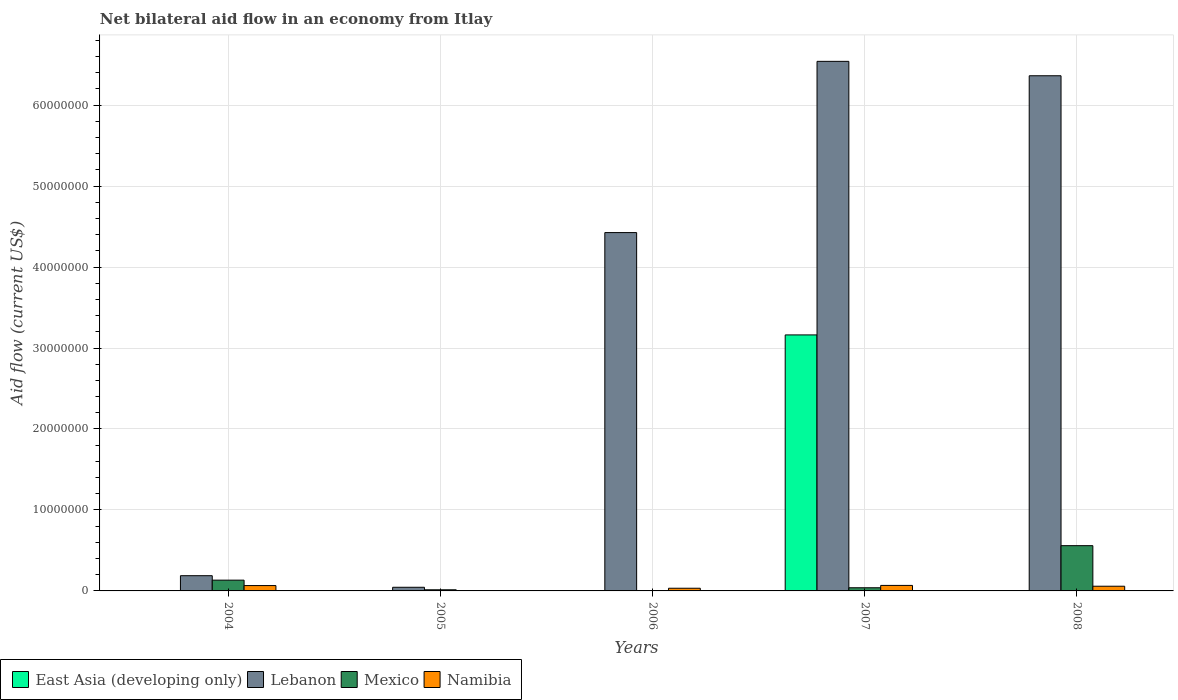How many different coloured bars are there?
Your answer should be compact. 4. How many groups of bars are there?
Your answer should be very brief. 5. How many bars are there on the 2nd tick from the right?
Ensure brevity in your answer.  4. In how many cases, is the number of bars for a given year not equal to the number of legend labels?
Keep it short and to the point. 4. What is the net bilateral aid flow in East Asia (developing only) in 2008?
Give a very brief answer. 0. Across all years, what is the maximum net bilateral aid flow in East Asia (developing only)?
Ensure brevity in your answer.  3.16e+07. Across all years, what is the minimum net bilateral aid flow in Lebanon?
Your response must be concise. 4.50e+05. In which year was the net bilateral aid flow in Namibia maximum?
Offer a very short reply. 2007. What is the total net bilateral aid flow in Namibia in the graph?
Keep it short and to the point. 2.26e+06. What is the difference between the net bilateral aid flow in Lebanon in 2005 and that in 2006?
Provide a succinct answer. -4.38e+07. What is the difference between the net bilateral aid flow in East Asia (developing only) in 2007 and the net bilateral aid flow in Mexico in 2006?
Ensure brevity in your answer.  3.16e+07. What is the average net bilateral aid flow in Mexico per year?
Make the answer very short. 1.49e+06. In the year 2007, what is the difference between the net bilateral aid flow in Namibia and net bilateral aid flow in Lebanon?
Offer a very short reply. -6.47e+07. What is the ratio of the net bilateral aid flow in Lebanon in 2007 to that in 2008?
Offer a terse response. 1.03. What is the difference between the highest and the lowest net bilateral aid flow in East Asia (developing only)?
Ensure brevity in your answer.  3.16e+07. In how many years, is the net bilateral aid flow in Mexico greater than the average net bilateral aid flow in Mexico taken over all years?
Give a very brief answer. 1. Is the sum of the net bilateral aid flow in Lebanon in 2004 and 2007 greater than the maximum net bilateral aid flow in East Asia (developing only) across all years?
Your answer should be very brief. Yes. Is it the case that in every year, the sum of the net bilateral aid flow in Namibia and net bilateral aid flow in Lebanon is greater than the net bilateral aid flow in Mexico?
Your answer should be very brief. Yes. Are the values on the major ticks of Y-axis written in scientific E-notation?
Offer a terse response. No. Where does the legend appear in the graph?
Your answer should be compact. Bottom left. What is the title of the graph?
Offer a terse response. Net bilateral aid flow in an economy from Itlay. Does "Vietnam" appear as one of the legend labels in the graph?
Keep it short and to the point. No. What is the Aid flow (current US$) in Lebanon in 2004?
Make the answer very short. 1.88e+06. What is the Aid flow (current US$) in Mexico in 2004?
Your response must be concise. 1.33e+06. What is the Aid flow (current US$) of East Asia (developing only) in 2005?
Keep it short and to the point. 0. What is the Aid flow (current US$) of Lebanon in 2006?
Keep it short and to the point. 4.43e+07. What is the Aid flow (current US$) of Mexico in 2006?
Offer a very short reply. 2.00e+04. What is the Aid flow (current US$) in East Asia (developing only) in 2007?
Provide a succinct answer. 3.16e+07. What is the Aid flow (current US$) in Lebanon in 2007?
Provide a short and direct response. 6.54e+07. What is the Aid flow (current US$) in Mexico in 2007?
Your answer should be compact. 3.90e+05. What is the Aid flow (current US$) in Namibia in 2007?
Keep it short and to the point. 6.80e+05. What is the Aid flow (current US$) of East Asia (developing only) in 2008?
Give a very brief answer. 0. What is the Aid flow (current US$) in Lebanon in 2008?
Make the answer very short. 6.36e+07. What is the Aid flow (current US$) of Mexico in 2008?
Ensure brevity in your answer.  5.59e+06. What is the Aid flow (current US$) of Namibia in 2008?
Make the answer very short. 5.80e+05. Across all years, what is the maximum Aid flow (current US$) in East Asia (developing only)?
Your response must be concise. 3.16e+07. Across all years, what is the maximum Aid flow (current US$) in Lebanon?
Make the answer very short. 6.54e+07. Across all years, what is the maximum Aid flow (current US$) in Mexico?
Your answer should be compact. 5.59e+06. Across all years, what is the maximum Aid flow (current US$) of Namibia?
Your answer should be very brief. 6.80e+05. Across all years, what is the minimum Aid flow (current US$) of Mexico?
Provide a short and direct response. 2.00e+04. What is the total Aid flow (current US$) of East Asia (developing only) in the graph?
Your answer should be compact. 3.16e+07. What is the total Aid flow (current US$) of Lebanon in the graph?
Provide a succinct answer. 1.76e+08. What is the total Aid flow (current US$) of Mexico in the graph?
Offer a terse response. 7.47e+06. What is the total Aid flow (current US$) of Namibia in the graph?
Give a very brief answer. 2.26e+06. What is the difference between the Aid flow (current US$) in Lebanon in 2004 and that in 2005?
Ensure brevity in your answer.  1.43e+06. What is the difference between the Aid flow (current US$) of Mexico in 2004 and that in 2005?
Provide a succinct answer. 1.19e+06. What is the difference between the Aid flow (current US$) in Namibia in 2004 and that in 2005?
Your response must be concise. 6.50e+05. What is the difference between the Aid flow (current US$) of Lebanon in 2004 and that in 2006?
Offer a very short reply. -4.24e+07. What is the difference between the Aid flow (current US$) of Mexico in 2004 and that in 2006?
Offer a terse response. 1.31e+06. What is the difference between the Aid flow (current US$) of Lebanon in 2004 and that in 2007?
Offer a very short reply. -6.35e+07. What is the difference between the Aid flow (current US$) in Mexico in 2004 and that in 2007?
Offer a very short reply. 9.40e+05. What is the difference between the Aid flow (current US$) of Lebanon in 2004 and that in 2008?
Give a very brief answer. -6.18e+07. What is the difference between the Aid flow (current US$) in Mexico in 2004 and that in 2008?
Offer a terse response. -4.26e+06. What is the difference between the Aid flow (current US$) of Lebanon in 2005 and that in 2006?
Provide a short and direct response. -4.38e+07. What is the difference between the Aid flow (current US$) in Mexico in 2005 and that in 2006?
Ensure brevity in your answer.  1.20e+05. What is the difference between the Aid flow (current US$) of Namibia in 2005 and that in 2006?
Offer a very short reply. -3.20e+05. What is the difference between the Aid flow (current US$) in Lebanon in 2005 and that in 2007?
Offer a terse response. -6.50e+07. What is the difference between the Aid flow (current US$) of Namibia in 2005 and that in 2007?
Your answer should be compact. -6.70e+05. What is the difference between the Aid flow (current US$) of Lebanon in 2005 and that in 2008?
Provide a short and direct response. -6.32e+07. What is the difference between the Aid flow (current US$) of Mexico in 2005 and that in 2008?
Make the answer very short. -5.45e+06. What is the difference between the Aid flow (current US$) of Namibia in 2005 and that in 2008?
Offer a very short reply. -5.70e+05. What is the difference between the Aid flow (current US$) in Lebanon in 2006 and that in 2007?
Provide a succinct answer. -2.12e+07. What is the difference between the Aid flow (current US$) of Mexico in 2006 and that in 2007?
Keep it short and to the point. -3.70e+05. What is the difference between the Aid flow (current US$) of Namibia in 2006 and that in 2007?
Make the answer very short. -3.50e+05. What is the difference between the Aid flow (current US$) in Lebanon in 2006 and that in 2008?
Provide a succinct answer. -1.94e+07. What is the difference between the Aid flow (current US$) of Mexico in 2006 and that in 2008?
Provide a short and direct response. -5.57e+06. What is the difference between the Aid flow (current US$) in Lebanon in 2007 and that in 2008?
Ensure brevity in your answer.  1.78e+06. What is the difference between the Aid flow (current US$) of Mexico in 2007 and that in 2008?
Offer a terse response. -5.20e+06. What is the difference between the Aid flow (current US$) in Namibia in 2007 and that in 2008?
Offer a very short reply. 1.00e+05. What is the difference between the Aid flow (current US$) of Lebanon in 2004 and the Aid flow (current US$) of Mexico in 2005?
Offer a very short reply. 1.74e+06. What is the difference between the Aid flow (current US$) in Lebanon in 2004 and the Aid flow (current US$) in Namibia in 2005?
Your response must be concise. 1.87e+06. What is the difference between the Aid flow (current US$) of Mexico in 2004 and the Aid flow (current US$) of Namibia in 2005?
Provide a short and direct response. 1.32e+06. What is the difference between the Aid flow (current US$) of Lebanon in 2004 and the Aid flow (current US$) of Mexico in 2006?
Provide a succinct answer. 1.86e+06. What is the difference between the Aid flow (current US$) of Lebanon in 2004 and the Aid flow (current US$) of Namibia in 2006?
Offer a terse response. 1.55e+06. What is the difference between the Aid flow (current US$) in Lebanon in 2004 and the Aid flow (current US$) in Mexico in 2007?
Ensure brevity in your answer.  1.49e+06. What is the difference between the Aid flow (current US$) of Lebanon in 2004 and the Aid flow (current US$) of Namibia in 2007?
Ensure brevity in your answer.  1.20e+06. What is the difference between the Aid flow (current US$) of Mexico in 2004 and the Aid flow (current US$) of Namibia in 2007?
Ensure brevity in your answer.  6.50e+05. What is the difference between the Aid flow (current US$) in Lebanon in 2004 and the Aid flow (current US$) in Mexico in 2008?
Your answer should be very brief. -3.71e+06. What is the difference between the Aid flow (current US$) of Lebanon in 2004 and the Aid flow (current US$) of Namibia in 2008?
Provide a succinct answer. 1.30e+06. What is the difference between the Aid flow (current US$) of Mexico in 2004 and the Aid flow (current US$) of Namibia in 2008?
Ensure brevity in your answer.  7.50e+05. What is the difference between the Aid flow (current US$) of Lebanon in 2005 and the Aid flow (current US$) of Namibia in 2006?
Your response must be concise. 1.20e+05. What is the difference between the Aid flow (current US$) of Lebanon in 2005 and the Aid flow (current US$) of Mexico in 2007?
Offer a very short reply. 6.00e+04. What is the difference between the Aid flow (current US$) in Mexico in 2005 and the Aid flow (current US$) in Namibia in 2007?
Your answer should be compact. -5.40e+05. What is the difference between the Aid flow (current US$) in Lebanon in 2005 and the Aid flow (current US$) in Mexico in 2008?
Ensure brevity in your answer.  -5.14e+06. What is the difference between the Aid flow (current US$) in Lebanon in 2005 and the Aid flow (current US$) in Namibia in 2008?
Ensure brevity in your answer.  -1.30e+05. What is the difference between the Aid flow (current US$) of Mexico in 2005 and the Aid flow (current US$) of Namibia in 2008?
Offer a terse response. -4.40e+05. What is the difference between the Aid flow (current US$) in Lebanon in 2006 and the Aid flow (current US$) in Mexico in 2007?
Your answer should be very brief. 4.39e+07. What is the difference between the Aid flow (current US$) of Lebanon in 2006 and the Aid flow (current US$) of Namibia in 2007?
Give a very brief answer. 4.36e+07. What is the difference between the Aid flow (current US$) of Mexico in 2006 and the Aid flow (current US$) of Namibia in 2007?
Your answer should be very brief. -6.60e+05. What is the difference between the Aid flow (current US$) in Lebanon in 2006 and the Aid flow (current US$) in Mexico in 2008?
Ensure brevity in your answer.  3.87e+07. What is the difference between the Aid flow (current US$) of Lebanon in 2006 and the Aid flow (current US$) of Namibia in 2008?
Offer a very short reply. 4.37e+07. What is the difference between the Aid flow (current US$) of Mexico in 2006 and the Aid flow (current US$) of Namibia in 2008?
Your answer should be very brief. -5.60e+05. What is the difference between the Aid flow (current US$) of East Asia (developing only) in 2007 and the Aid flow (current US$) of Lebanon in 2008?
Offer a terse response. -3.20e+07. What is the difference between the Aid flow (current US$) of East Asia (developing only) in 2007 and the Aid flow (current US$) of Mexico in 2008?
Offer a terse response. 2.60e+07. What is the difference between the Aid flow (current US$) in East Asia (developing only) in 2007 and the Aid flow (current US$) in Namibia in 2008?
Make the answer very short. 3.10e+07. What is the difference between the Aid flow (current US$) in Lebanon in 2007 and the Aid flow (current US$) in Mexico in 2008?
Your response must be concise. 5.98e+07. What is the difference between the Aid flow (current US$) in Lebanon in 2007 and the Aid flow (current US$) in Namibia in 2008?
Your answer should be compact. 6.48e+07. What is the difference between the Aid flow (current US$) of Mexico in 2007 and the Aid flow (current US$) of Namibia in 2008?
Make the answer very short. -1.90e+05. What is the average Aid flow (current US$) in East Asia (developing only) per year?
Your answer should be compact. 6.32e+06. What is the average Aid flow (current US$) of Lebanon per year?
Ensure brevity in your answer.  3.51e+07. What is the average Aid flow (current US$) of Mexico per year?
Your answer should be compact. 1.49e+06. What is the average Aid flow (current US$) of Namibia per year?
Your answer should be compact. 4.52e+05. In the year 2004, what is the difference between the Aid flow (current US$) in Lebanon and Aid flow (current US$) in Namibia?
Your response must be concise. 1.22e+06. In the year 2004, what is the difference between the Aid flow (current US$) of Mexico and Aid flow (current US$) of Namibia?
Provide a short and direct response. 6.70e+05. In the year 2005, what is the difference between the Aid flow (current US$) of Lebanon and Aid flow (current US$) of Namibia?
Provide a succinct answer. 4.40e+05. In the year 2006, what is the difference between the Aid flow (current US$) of Lebanon and Aid flow (current US$) of Mexico?
Your answer should be compact. 4.42e+07. In the year 2006, what is the difference between the Aid flow (current US$) of Lebanon and Aid flow (current US$) of Namibia?
Provide a succinct answer. 4.39e+07. In the year 2006, what is the difference between the Aid flow (current US$) of Mexico and Aid flow (current US$) of Namibia?
Your response must be concise. -3.10e+05. In the year 2007, what is the difference between the Aid flow (current US$) in East Asia (developing only) and Aid flow (current US$) in Lebanon?
Keep it short and to the point. -3.38e+07. In the year 2007, what is the difference between the Aid flow (current US$) of East Asia (developing only) and Aid flow (current US$) of Mexico?
Offer a very short reply. 3.12e+07. In the year 2007, what is the difference between the Aid flow (current US$) of East Asia (developing only) and Aid flow (current US$) of Namibia?
Your response must be concise. 3.09e+07. In the year 2007, what is the difference between the Aid flow (current US$) in Lebanon and Aid flow (current US$) in Mexico?
Provide a short and direct response. 6.50e+07. In the year 2007, what is the difference between the Aid flow (current US$) of Lebanon and Aid flow (current US$) of Namibia?
Provide a short and direct response. 6.47e+07. In the year 2008, what is the difference between the Aid flow (current US$) in Lebanon and Aid flow (current US$) in Mexico?
Provide a succinct answer. 5.80e+07. In the year 2008, what is the difference between the Aid flow (current US$) in Lebanon and Aid flow (current US$) in Namibia?
Offer a very short reply. 6.30e+07. In the year 2008, what is the difference between the Aid flow (current US$) of Mexico and Aid flow (current US$) of Namibia?
Make the answer very short. 5.01e+06. What is the ratio of the Aid flow (current US$) in Lebanon in 2004 to that in 2005?
Your response must be concise. 4.18. What is the ratio of the Aid flow (current US$) of Lebanon in 2004 to that in 2006?
Provide a short and direct response. 0.04. What is the ratio of the Aid flow (current US$) of Mexico in 2004 to that in 2006?
Make the answer very short. 66.5. What is the ratio of the Aid flow (current US$) in Lebanon in 2004 to that in 2007?
Ensure brevity in your answer.  0.03. What is the ratio of the Aid flow (current US$) of Mexico in 2004 to that in 2007?
Offer a very short reply. 3.41. What is the ratio of the Aid flow (current US$) of Namibia in 2004 to that in 2007?
Provide a succinct answer. 0.97. What is the ratio of the Aid flow (current US$) in Lebanon in 2004 to that in 2008?
Offer a very short reply. 0.03. What is the ratio of the Aid flow (current US$) in Mexico in 2004 to that in 2008?
Offer a terse response. 0.24. What is the ratio of the Aid flow (current US$) in Namibia in 2004 to that in 2008?
Give a very brief answer. 1.14. What is the ratio of the Aid flow (current US$) in Lebanon in 2005 to that in 2006?
Keep it short and to the point. 0.01. What is the ratio of the Aid flow (current US$) in Mexico in 2005 to that in 2006?
Provide a short and direct response. 7. What is the ratio of the Aid flow (current US$) in Namibia in 2005 to that in 2006?
Your answer should be very brief. 0.03. What is the ratio of the Aid flow (current US$) in Lebanon in 2005 to that in 2007?
Your answer should be compact. 0.01. What is the ratio of the Aid flow (current US$) of Mexico in 2005 to that in 2007?
Provide a succinct answer. 0.36. What is the ratio of the Aid flow (current US$) of Namibia in 2005 to that in 2007?
Make the answer very short. 0.01. What is the ratio of the Aid flow (current US$) of Lebanon in 2005 to that in 2008?
Your answer should be very brief. 0.01. What is the ratio of the Aid flow (current US$) of Mexico in 2005 to that in 2008?
Give a very brief answer. 0.03. What is the ratio of the Aid flow (current US$) of Namibia in 2005 to that in 2008?
Your response must be concise. 0.02. What is the ratio of the Aid flow (current US$) of Lebanon in 2006 to that in 2007?
Ensure brevity in your answer.  0.68. What is the ratio of the Aid flow (current US$) in Mexico in 2006 to that in 2007?
Keep it short and to the point. 0.05. What is the ratio of the Aid flow (current US$) of Namibia in 2006 to that in 2007?
Ensure brevity in your answer.  0.49. What is the ratio of the Aid flow (current US$) in Lebanon in 2006 to that in 2008?
Offer a terse response. 0.7. What is the ratio of the Aid flow (current US$) of Mexico in 2006 to that in 2008?
Make the answer very short. 0. What is the ratio of the Aid flow (current US$) in Namibia in 2006 to that in 2008?
Provide a short and direct response. 0.57. What is the ratio of the Aid flow (current US$) in Lebanon in 2007 to that in 2008?
Provide a short and direct response. 1.03. What is the ratio of the Aid flow (current US$) of Mexico in 2007 to that in 2008?
Your answer should be very brief. 0.07. What is the ratio of the Aid flow (current US$) of Namibia in 2007 to that in 2008?
Offer a terse response. 1.17. What is the difference between the highest and the second highest Aid flow (current US$) of Lebanon?
Give a very brief answer. 1.78e+06. What is the difference between the highest and the second highest Aid flow (current US$) in Mexico?
Keep it short and to the point. 4.26e+06. What is the difference between the highest and the second highest Aid flow (current US$) of Namibia?
Make the answer very short. 2.00e+04. What is the difference between the highest and the lowest Aid flow (current US$) of East Asia (developing only)?
Provide a succinct answer. 3.16e+07. What is the difference between the highest and the lowest Aid flow (current US$) of Lebanon?
Ensure brevity in your answer.  6.50e+07. What is the difference between the highest and the lowest Aid flow (current US$) of Mexico?
Provide a succinct answer. 5.57e+06. What is the difference between the highest and the lowest Aid flow (current US$) of Namibia?
Offer a very short reply. 6.70e+05. 